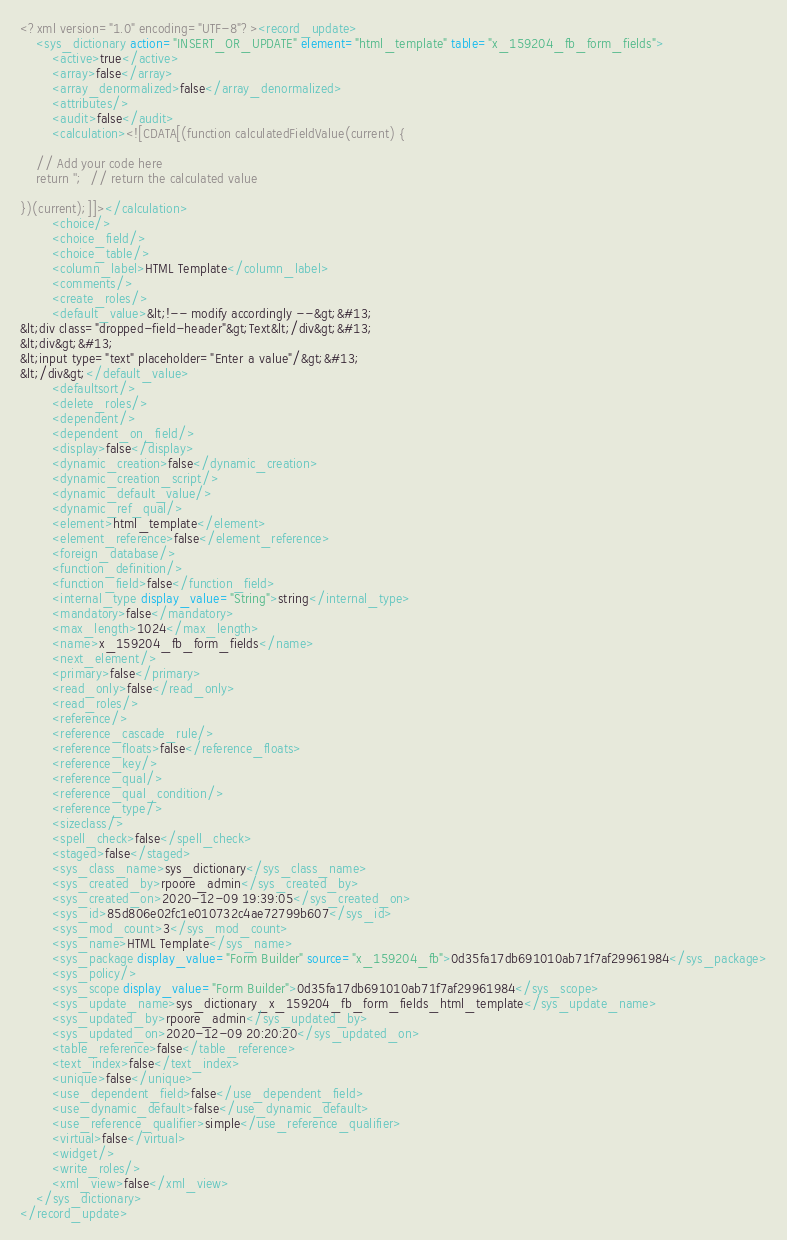Convert code to text. <code><loc_0><loc_0><loc_500><loc_500><_XML_><?xml version="1.0" encoding="UTF-8"?><record_update>
    <sys_dictionary action="INSERT_OR_UPDATE" element="html_template" table="x_159204_fb_form_fields">
        <active>true</active>
        <array>false</array>
        <array_denormalized>false</array_denormalized>
        <attributes/>
        <audit>false</audit>
        <calculation><![CDATA[(function calculatedFieldValue(current) {

	// Add your code here
	return '';  // return the calculated value

})(current);]]></calculation>
        <choice/>
        <choice_field/>
        <choice_table/>
        <column_label>HTML Template</column_label>
        <comments/>
        <create_roles/>
        <default_value>&lt;!-- modify accordingly --&gt;&#13;
&lt;div class="dropped-field-header"&gt;Text&lt;/div&gt;&#13;
&lt;div&gt;&#13;
&lt;input type="text" placeholder="Enter a value"/&gt;&#13;
&lt;/div&gt;</default_value>
        <defaultsort/>
        <delete_roles/>
        <dependent/>
        <dependent_on_field/>
        <display>false</display>
        <dynamic_creation>false</dynamic_creation>
        <dynamic_creation_script/>
        <dynamic_default_value/>
        <dynamic_ref_qual/>
        <element>html_template</element>
        <element_reference>false</element_reference>
        <foreign_database/>
        <function_definition/>
        <function_field>false</function_field>
        <internal_type display_value="String">string</internal_type>
        <mandatory>false</mandatory>
        <max_length>1024</max_length>
        <name>x_159204_fb_form_fields</name>
        <next_element/>
        <primary>false</primary>
        <read_only>false</read_only>
        <read_roles/>
        <reference/>
        <reference_cascade_rule/>
        <reference_floats>false</reference_floats>
        <reference_key/>
        <reference_qual/>
        <reference_qual_condition/>
        <reference_type/>
        <sizeclass/>
        <spell_check>false</spell_check>
        <staged>false</staged>
        <sys_class_name>sys_dictionary</sys_class_name>
        <sys_created_by>rpoore_admin</sys_created_by>
        <sys_created_on>2020-12-09 19:39:05</sys_created_on>
        <sys_id>85d806e02fc1e010732c4ae72799b607</sys_id>
        <sys_mod_count>3</sys_mod_count>
        <sys_name>HTML Template</sys_name>
        <sys_package display_value="Form Builder" source="x_159204_fb">0d35fa17db691010ab71f7af29961984</sys_package>
        <sys_policy/>
        <sys_scope display_value="Form Builder">0d35fa17db691010ab71f7af29961984</sys_scope>
        <sys_update_name>sys_dictionary_x_159204_fb_form_fields_html_template</sys_update_name>
        <sys_updated_by>rpoore_admin</sys_updated_by>
        <sys_updated_on>2020-12-09 20:20:20</sys_updated_on>
        <table_reference>false</table_reference>
        <text_index>false</text_index>
        <unique>false</unique>
        <use_dependent_field>false</use_dependent_field>
        <use_dynamic_default>false</use_dynamic_default>
        <use_reference_qualifier>simple</use_reference_qualifier>
        <virtual>false</virtual>
        <widget/>
        <write_roles/>
        <xml_view>false</xml_view>
    </sys_dictionary>
</record_update>
</code> 